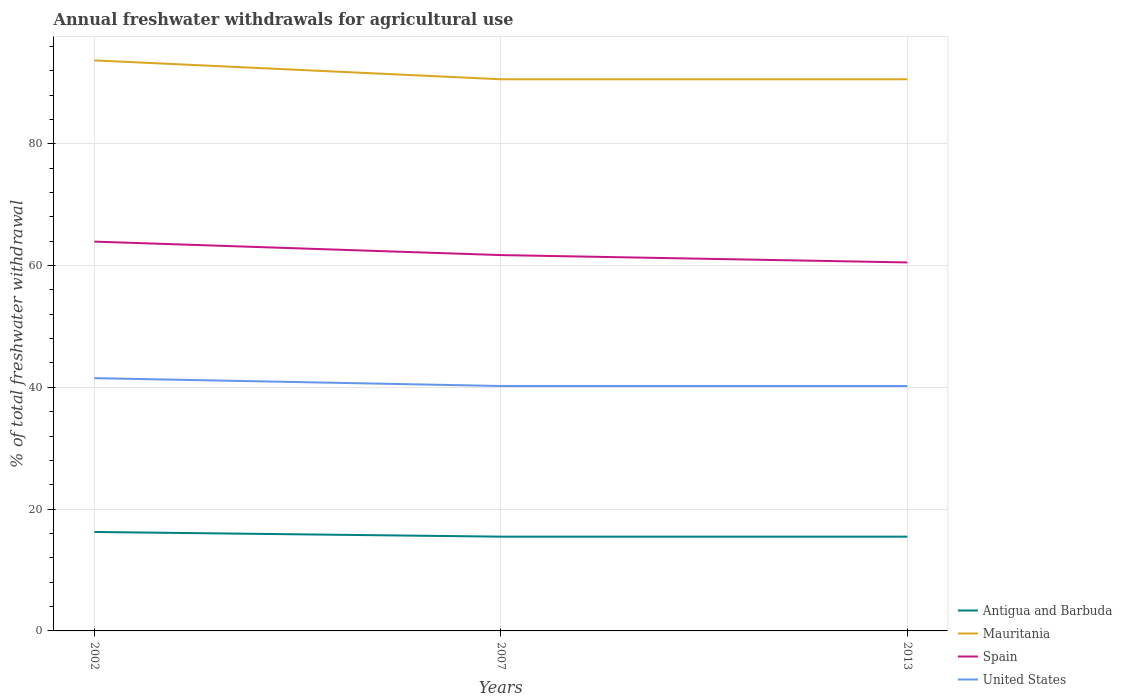How many different coloured lines are there?
Your answer should be very brief. 4. Across all years, what is the maximum total annual withdrawals from freshwater in Mauritania?
Offer a very short reply. 90.59. What is the total total annual withdrawals from freshwater in United States in the graph?
Your answer should be compact. 1.29. What is the difference between the highest and the second highest total annual withdrawals from freshwater in United States?
Provide a succinct answer. 1.29. What is the difference between the highest and the lowest total annual withdrawals from freshwater in Mauritania?
Your answer should be very brief. 1. Is the total annual withdrawals from freshwater in United States strictly greater than the total annual withdrawals from freshwater in Antigua and Barbuda over the years?
Offer a terse response. No. How many lines are there?
Your response must be concise. 4. Are the values on the major ticks of Y-axis written in scientific E-notation?
Offer a terse response. No. How many legend labels are there?
Your answer should be compact. 4. How are the legend labels stacked?
Your answer should be very brief. Vertical. What is the title of the graph?
Your answer should be compact. Annual freshwater withdrawals for agricultural use. Does "Isle of Man" appear as one of the legend labels in the graph?
Make the answer very short. No. What is the label or title of the Y-axis?
Provide a short and direct response. % of total freshwater withdrawal. What is the % of total freshwater withdrawal in Antigua and Barbuda in 2002?
Provide a short and direct response. 16.25. What is the % of total freshwater withdrawal in Mauritania in 2002?
Ensure brevity in your answer.  93.69. What is the % of total freshwater withdrawal in Spain in 2002?
Provide a succinct answer. 63.93. What is the % of total freshwater withdrawal of United States in 2002?
Keep it short and to the point. 41.51. What is the % of total freshwater withdrawal of Antigua and Barbuda in 2007?
Provide a succinct answer. 15.48. What is the % of total freshwater withdrawal of Mauritania in 2007?
Ensure brevity in your answer.  90.59. What is the % of total freshwater withdrawal in Spain in 2007?
Make the answer very short. 61.72. What is the % of total freshwater withdrawal of United States in 2007?
Your answer should be compact. 40.22. What is the % of total freshwater withdrawal in Antigua and Barbuda in 2013?
Make the answer very short. 15.48. What is the % of total freshwater withdrawal in Mauritania in 2013?
Your answer should be very brief. 90.59. What is the % of total freshwater withdrawal of Spain in 2013?
Provide a short and direct response. 60.51. What is the % of total freshwater withdrawal in United States in 2013?
Your answer should be very brief. 40.22. Across all years, what is the maximum % of total freshwater withdrawal in Antigua and Barbuda?
Offer a very short reply. 16.25. Across all years, what is the maximum % of total freshwater withdrawal of Mauritania?
Make the answer very short. 93.69. Across all years, what is the maximum % of total freshwater withdrawal of Spain?
Your answer should be compact. 63.93. Across all years, what is the maximum % of total freshwater withdrawal in United States?
Offer a terse response. 41.51. Across all years, what is the minimum % of total freshwater withdrawal of Antigua and Barbuda?
Offer a terse response. 15.48. Across all years, what is the minimum % of total freshwater withdrawal in Mauritania?
Keep it short and to the point. 90.59. Across all years, what is the minimum % of total freshwater withdrawal of Spain?
Your response must be concise. 60.51. Across all years, what is the minimum % of total freshwater withdrawal in United States?
Give a very brief answer. 40.22. What is the total % of total freshwater withdrawal of Antigua and Barbuda in the graph?
Your answer should be very brief. 47.21. What is the total % of total freshwater withdrawal in Mauritania in the graph?
Your answer should be compact. 274.87. What is the total % of total freshwater withdrawal in Spain in the graph?
Give a very brief answer. 186.16. What is the total % of total freshwater withdrawal of United States in the graph?
Offer a very short reply. 121.95. What is the difference between the % of total freshwater withdrawal in Antigua and Barbuda in 2002 and that in 2007?
Offer a terse response. 0.77. What is the difference between the % of total freshwater withdrawal of Spain in 2002 and that in 2007?
Your answer should be compact. 2.21. What is the difference between the % of total freshwater withdrawal in United States in 2002 and that in 2007?
Provide a short and direct response. 1.29. What is the difference between the % of total freshwater withdrawal in Antigua and Barbuda in 2002 and that in 2013?
Offer a terse response. 0.77. What is the difference between the % of total freshwater withdrawal in Spain in 2002 and that in 2013?
Offer a terse response. 3.42. What is the difference between the % of total freshwater withdrawal in United States in 2002 and that in 2013?
Keep it short and to the point. 1.29. What is the difference between the % of total freshwater withdrawal in Antigua and Barbuda in 2007 and that in 2013?
Keep it short and to the point. 0. What is the difference between the % of total freshwater withdrawal of Mauritania in 2007 and that in 2013?
Offer a very short reply. 0. What is the difference between the % of total freshwater withdrawal in Spain in 2007 and that in 2013?
Give a very brief answer. 1.21. What is the difference between the % of total freshwater withdrawal of United States in 2007 and that in 2013?
Your response must be concise. 0. What is the difference between the % of total freshwater withdrawal in Antigua and Barbuda in 2002 and the % of total freshwater withdrawal in Mauritania in 2007?
Offer a very short reply. -74.34. What is the difference between the % of total freshwater withdrawal of Antigua and Barbuda in 2002 and the % of total freshwater withdrawal of Spain in 2007?
Provide a succinct answer. -45.47. What is the difference between the % of total freshwater withdrawal in Antigua and Barbuda in 2002 and the % of total freshwater withdrawal in United States in 2007?
Ensure brevity in your answer.  -23.97. What is the difference between the % of total freshwater withdrawal in Mauritania in 2002 and the % of total freshwater withdrawal in Spain in 2007?
Offer a very short reply. 31.97. What is the difference between the % of total freshwater withdrawal in Mauritania in 2002 and the % of total freshwater withdrawal in United States in 2007?
Provide a succinct answer. 53.47. What is the difference between the % of total freshwater withdrawal in Spain in 2002 and the % of total freshwater withdrawal in United States in 2007?
Ensure brevity in your answer.  23.71. What is the difference between the % of total freshwater withdrawal of Antigua and Barbuda in 2002 and the % of total freshwater withdrawal of Mauritania in 2013?
Offer a very short reply. -74.34. What is the difference between the % of total freshwater withdrawal in Antigua and Barbuda in 2002 and the % of total freshwater withdrawal in Spain in 2013?
Make the answer very short. -44.26. What is the difference between the % of total freshwater withdrawal in Antigua and Barbuda in 2002 and the % of total freshwater withdrawal in United States in 2013?
Ensure brevity in your answer.  -23.97. What is the difference between the % of total freshwater withdrawal of Mauritania in 2002 and the % of total freshwater withdrawal of Spain in 2013?
Provide a succinct answer. 33.18. What is the difference between the % of total freshwater withdrawal in Mauritania in 2002 and the % of total freshwater withdrawal in United States in 2013?
Your answer should be very brief. 53.47. What is the difference between the % of total freshwater withdrawal of Spain in 2002 and the % of total freshwater withdrawal of United States in 2013?
Your response must be concise. 23.71. What is the difference between the % of total freshwater withdrawal of Antigua and Barbuda in 2007 and the % of total freshwater withdrawal of Mauritania in 2013?
Provide a succinct answer. -75.11. What is the difference between the % of total freshwater withdrawal of Antigua and Barbuda in 2007 and the % of total freshwater withdrawal of Spain in 2013?
Your response must be concise. -45.03. What is the difference between the % of total freshwater withdrawal in Antigua and Barbuda in 2007 and the % of total freshwater withdrawal in United States in 2013?
Provide a succinct answer. -24.74. What is the difference between the % of total freshwater withdrawal of Mauritania in 2007 and the % of total freshwater withdrawal of Spain in 2013?
Offer a terse response. 30.08. What is the difference between the % of total freshwater withdrawal of Mauritania in 2007 and the % of total freshwater withdrawal of United States in 2013?
Your answer should be compact. 50.37. What is the average % of total freshwater withdrawal in Antigua and Barbuda per year?
Your answer should be compact. 15.74. What is the average % of total freshwater withdrawal in Mauritania per year?
Provide a short and direct response. 91.62. What is the average % of total freshwater withdrawal of Spain per year?
Keep it short and to the point. 62.05. What is the average % of total freshwater withdrawal of United States per year?
Provide a short and direct response. 40.65. In the year 2002, what is the difference between the % of total freshwater withdrawal of Antigua and Barbuda and % of total freshwater withdrawal of Mauritania?
Provide a short and direct response. -77.44. In the year 2002, what is the difference between the % of total freshwater withdrawal of Antigua and Barbuda and % of total freshwater withdrawal of Spain?
Ensure brevity in your answer.  -47.68. In the year 2002, what is the difference between the % of total freshwater withdrawal in Antigua and Barbuda and % of total freshwater withdrawal in United States?
Give a very brief answer. -25.26. In the year 2002, what is the difference between the % of total freshwater withdrawal of Mauritania and % of total freshwater withdrawal of Spain?
Offer a terse response. 29.76. In the year 2002, what is the difference between the % of total freshwater withdrawal in Mauritania and % of total freshwater withdrawal in United States?
Your response must be concise. 52.18. In the year 2002, what is the difference between the % of total freshwater withdrawal in Spain and % of total freshwater withdrawal in United States?
Give a very brief answer. 22.42. In the year 2007, what is the difference between the % of total freshwater withdrawal of Antigua and Barbuda and % of total freshwater withdrawal of Mauritania?
Provide a succinct answer. -75.11. In the year 2007, what is the difference between the % of total freshwater withdrawal of Antigua and Barbuda and % of total freshwater withdrawal of Spain?
Your answer should be compact. -46.24. In the year 2007, what is the difference between the % of total freshwater withdrawal in Antigua and Barbuda and % of total freshwater withdrawal in United States?
Provide a short and direct response. -24.74. In the year 2007, what is the difference between the % of total freshwater withdrawal in Mauritania and % of total freshwater withdrawal in Spain?
Give a very brief answer. 28.87. In the year 2007, what is the difference between the % of total freshwater withdrawal of Mauritania and % of total freshwater withdrawal of United States?
Provide a short and direct response. 50.37. In the year 2007, what is the difference between the % of total freshwater withdrawal of Spain and % of total freshwater withdrawal of United States?
Keep it short and to the point. 21.5. In the year 2013, what is the difference between the % of total freshwater withdrawal of Antigua and Barbuda and % of total freshwater withdrawal of Mauritania?
Offer a very short reply. -75.11. In the year 2013, what is the difference between the % of total freshwater withdrawal of Antigua and Barbuda and % of total freshwater withdrawal of Spain?
Give a very brief answer. -45.03. In the year 2013, what is the difference between the % of total freshwater withdrawal of Antigua and Barbuda and % of total freshwater withdrawal of United States?
Ensure brevity in your answer.  -24.74. In the year 2013, what is the difference between the % of total freshwater withdrawal of Mauritania and % of total freshwater withdrawal of Spain?
Offer a very short reply. 30.08. In the year 2013, what is the difference between the % of total freshwater withdrawal in Mauritania and % of total freshwater withdrawal in United States?
Provide a short and direct response. 50.37. In the year 2013, what is the difference between the % of total freshwater withdrawal in Spain and % of total freshwater withdrawal in United States?
Provide a short and direct response. 20.29. What is the ratio of the % of total freshwater withdrawal in Antigua and Barbuda in 2002 to that in 2007?
Ensure brevity in your answer.  1.05. What is the ratio of the % of total freshwater withdrawal of Mauritania in 2002 to that in 2007?
Your answer should be compact. 1.03. What is the ratio of the % of total freshwater withdrawal of Spain in 2002 to that in 2007?
Provide a short and direct response. 1.04. What is the ratio of the % of total freshwater withdrawal in United States in 2002 to that in 2007?
Your answer should be very brief. 1.03. What is the ratio of the % of total freshwater withdrawal of Antigua and Barbuda in 2002 to that in 2013?
Make the answer very short. 1.05. What is the ratio of the % of total freshwater withdrawal in Mauritania in 2002 to that in 2013?
Provide a succinct answer. 1.03. What is the ratio of the % of total freshwater withdrawal in Spain in 2002 to that in 2013?
Your response must be concise. 1.06. What is the ratio of the % of total freshwater withdrawal in United States in 2002 to that in 2013?
Keep it short and to the point. 1.03. What is the ratio of the % of total freshwater withdrawal in Antigua and Barbuda in 2007 to that in 2013?
Provide a succinct answer. 1. What is the ratio of the % of total freshwater withdrawal in United States in 2007 to that in 2013?
Your answer should be very brief. 1. What is the difference between the highest and the second highest % of total freshwater withdrawal in Antigua and Barbuda?
Your response must be concise. 0.77. What is the difference between the highest and the second highest % of total freshwater withdrawal in Mauritania?
Keep it short and to the point. 3.1. What is the difference between the highest and the second highest % of total freshwater withdrawal in Spain?
Your answer should be very brief. 2.21. What is the difference between the highest and the second highest % of total freshwater withdrawal in United States?
Provide a succinct answer. 1.29. What is the difference between the highest and the lowest % of total freshwater withdrawal in Antigua and Barbuda?
Keep it short and to the point. 0.77. What is the difference between the highest and the lowest % of total freshwater withdrawal of Mauritania?
Give a very brief answer. 3.1. What is the difference between the highest and the lowest % of total freshwater withdrawal of Spain?
Provide a succinct answer. 3.42. What is the difference between the highest and the lowest % of total freshwater withdrawal in United States?
Keep it short and to the point. 1.29. 